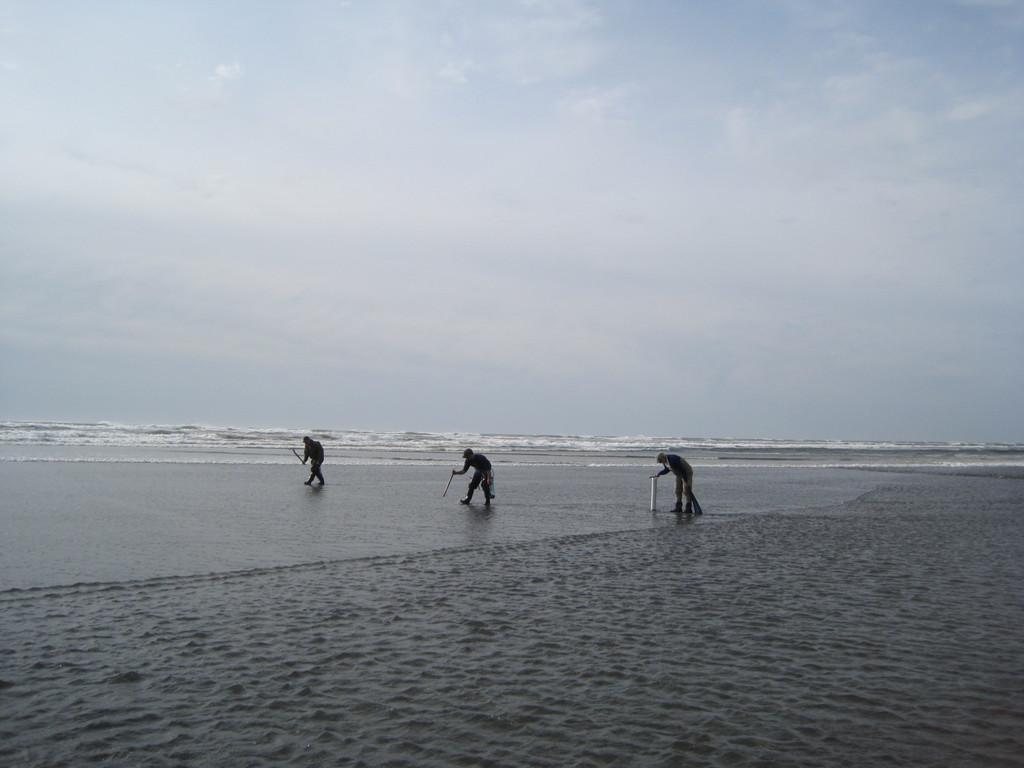Describe this image in one or two sentences. In the picture we can see a beach view with a sand and some people are bending and walking with a stick and in the background, we can see a water with white tides and a sky with clouds. 